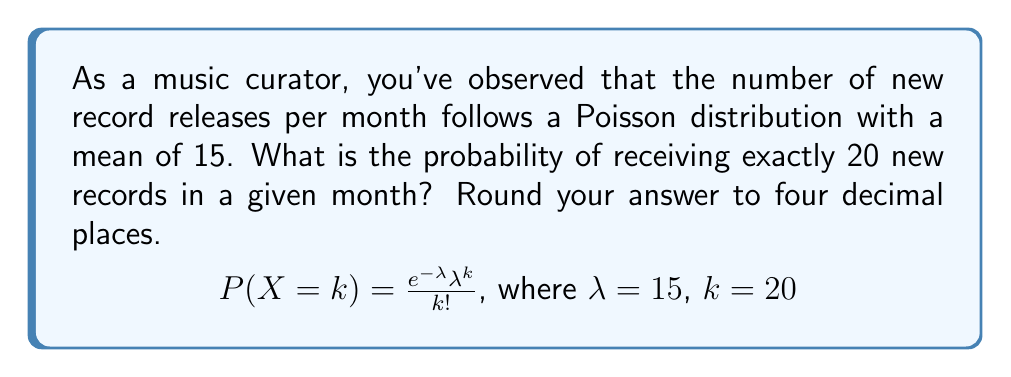Teach me how to tackle this problem. To solve this problem, we'll use the Poisson probability mass function:

$$P(X = k) = \frac{e^{-\lambda} \lambda^k}{k!}$$

Where:
$\lambda$ = mean number of events (new record releases) per interval (month)
$k$ = number of events we're calculating the probability for
$e$ = Euler's number (approximately 2.71828)

Given:
$\lambda = 15$
$k = 20$

Step 1: Substitute the values into the formula:

$$P(X = 20) = \frac{e^{-15} 15^{20}}{20!}$$

Step 2: Calculate the numerator:
$e^{-15} \approx 3.0590 \times 10^{-7}$
$15^{20} = 3.2863 \times 10^{23}$

Step 3: Calculate the denominator:
$20! = 2.4329 \times 10^{18}$

Step 4: Divide the numerator by the denominator:

$$\frac{(3.0590 \times 10^{-7})(3.2863 \times 10^{23})}{2.4329 \times 10^{18}} \approx 0.0415$$

Step 5: Round to four decimal places:

$0.0415 \approx 0.0415$
Answer: 0.0415 